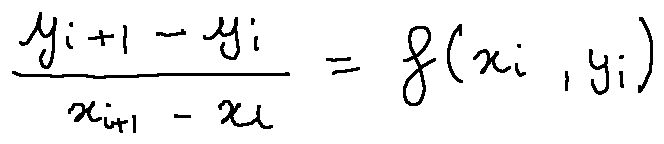<formula> <loc_0><loc_0><loc_500><loc_500>\frac { y _ { i + 1 } - y _ { i } } { x _ { i + 1 } - x _ { i } } = f ( x _ { i } , y _ { i } )</formula> 